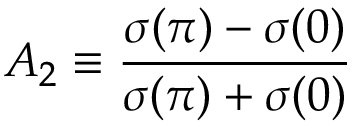<formula> <loc_0><loc_0><loc_500><loc_500>A _ { 2 } \equiv \frac { \sigma ( \pi ) - \sigma ( 0 ) } { \sigma ( \pi ) + \sigma ( 0 ) }</formula> 